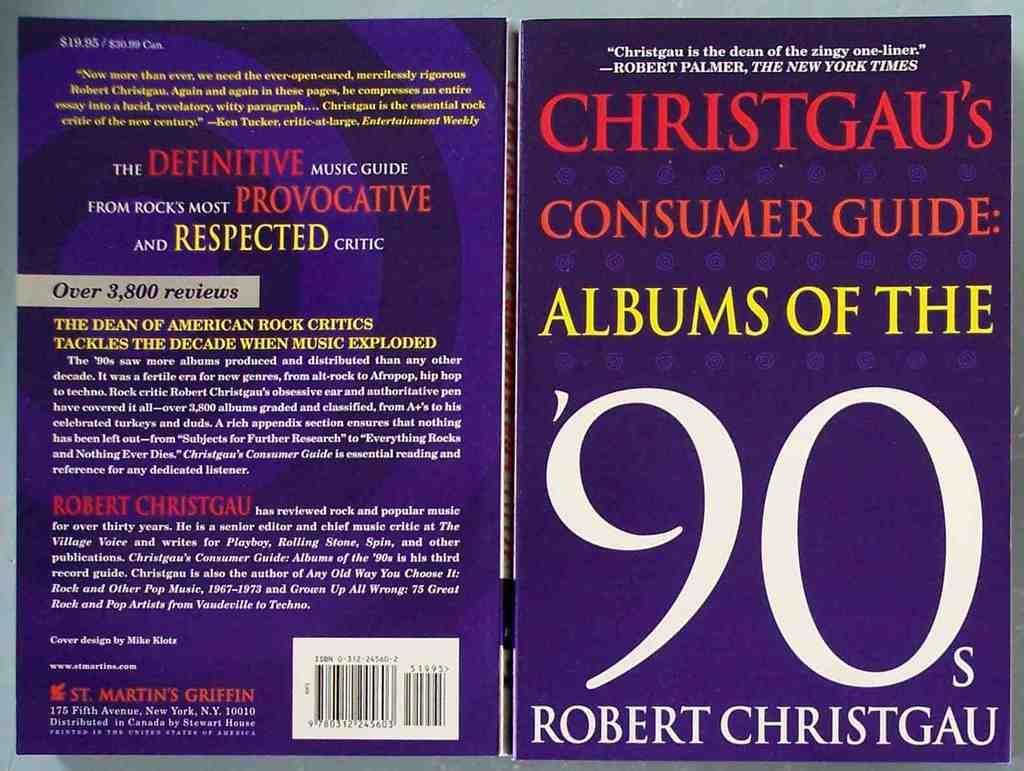Provide a one-sentence caption for the provided image. purple book, christgau's consumer guide: albums of the '90s. 